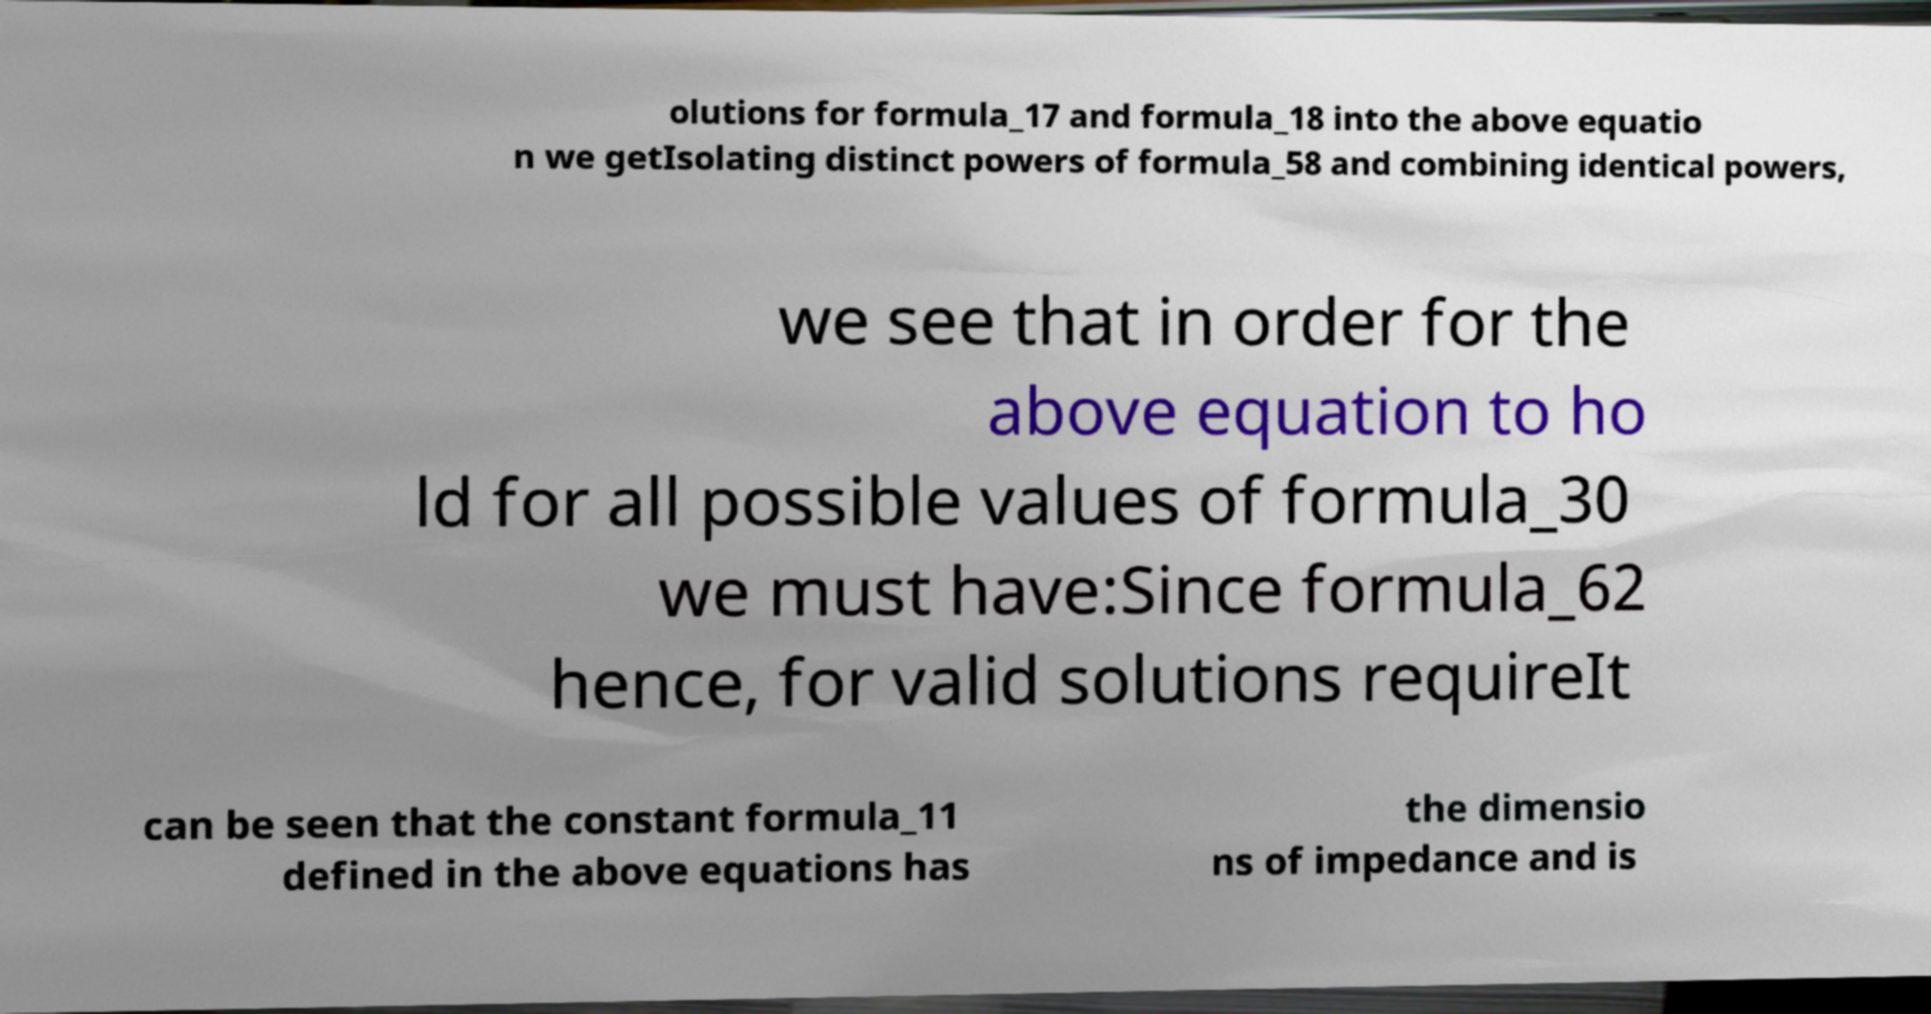Please identify and transcribe the text found in this image. olutions for formula_17 and formula_18 into the above equatio n we getIsolating distinct powers of formula_58 and combining identical powers, we see that in order for the above equation to ho ld for all possible values of formula_30 we must have:Since formula_62 hence, for valid solutions requireIt can be seen that the constant formula_11 defined in the above equations has the dimensio ns of impedance and is 